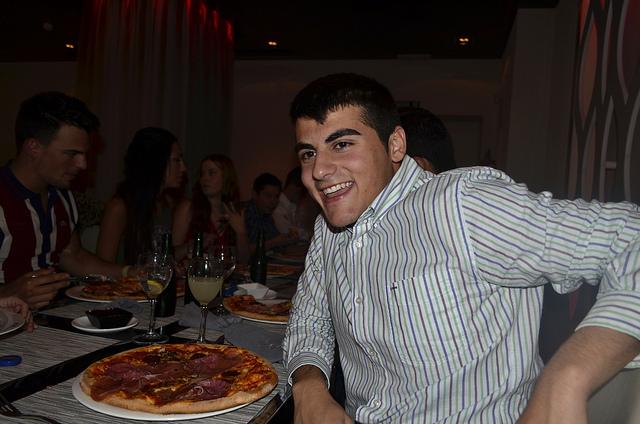What color is the man's shirt?
Quick response, please. White. What kind of food is on the table?
Be succinct. Pizza. What kind of oven was used to cook the pizza?
Give a very brief answer. Brick. What is on the man's pizza?
Quick response, please. Pepperoni. Is the pizza homemade?
Give a very brief answer. No. How many people do you see?
Be succinct. 7. Is there a "sippy" cup in front of the adult?
Answer briefly. No. Is the man wearing glasses?
Short answer required. No. Is there a laptop in front of the young man?
Quick response, please. No. What else are we eating besides pizza?
Write a very short answer. Cake. What room is this person in?
Answer briefly. Dining room. How many of the utensils are pink?
Short answer required. 0. What is this man drinking?
Keep it brief. Wine. Does the person have 20/20 vision?
Give a very brief answer. Yes. Does the man appear to be thinking?
Concise answer only. No. How many slices of pizza are left?
Quick response, please. 8. What kind of fruit is in one of the wine glasses?
Be succinct. Lemon. What color eyes does the man have?
Keep it brief. Brown. What is for lunch?
Answer briefly. Pizza. 